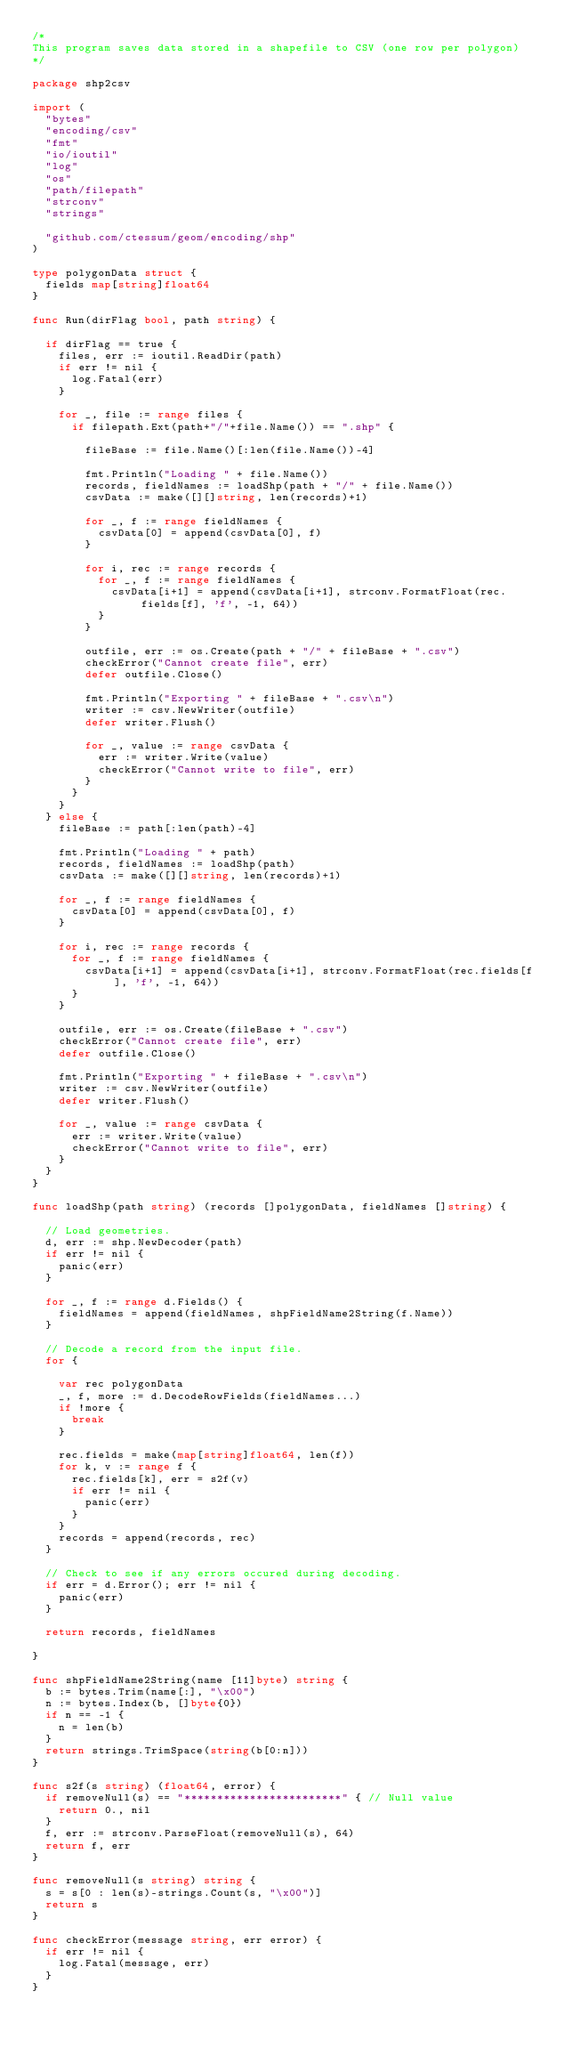<code> <loc_0><loc_0><loc_500><loc_500><_Go_>/*
This program saves data stored in a shapefile to CSV (one row per polygon)
*/

package shp2csv

import (
	"bytes"
	"encoding/csv"
	"fmt"
	"io/ioutil"
	"log"
	"os"
	"path/filepath"
	"strconv"
	"strings"

	"github.com/ctessum/geom/encoding/shp"
)

type polygonData struct {
	fields map[string]float64
}

func Run(dirFlag bool, path string) {

	if dirFlag == true {
		files, err := ioutil.ReadDir(path)
		if err != nil {
			log.Fatal(err)
		}

		for _, file := range files {
			if filepath.Ext(path+"/"+file.Name()) == ".shp" {

				fileBase := file.Name()[:len(file.Name())-4]

				fmt.Println("Loading " + file.Name())
				records, fieldNames := loadShp(path + "/" + file.Name())
				csvData := make([][]string, len(records)+1)

				for _, f := range fieldNames {
					csvData[0] = append(csvData[0], f)
				}

				for i, rec := range records {
					for _, f := range fieldNames {
						csvData[i+1] = append(csvData[i+1], strconv.FormatFloat(rec.fields[f], 'f', -1, 64))
					}
				}

				outfile, err := os.Create(path + "/" + fileBase + ".csv")
				checkError("Cannot create file", err)
				defer outfile.Close()

				fmt.Println("Exporting " + fileBase + ".csv\n")
				writer := csv.NewWriter(outfile)
				defer writer.Flush()

				for _, value := range csvData {
					err := writer.Write(value)
					checkError("Cannot write to file", err)
				}
			}
		}
	} else {
		fileBase := path[:len(path)-4]

		fmt.Println("Loading " + path)
		records, fieldNames := loadShp(path)
		csvData := make([][]string, len(records)+1)

		for _, f := range fieldNames {
			csvData[0] = append(csvData[0], f)
		}

		for i, rec := range records {
			for _, f := range fieldNames {
				csvData[i+1] = append(csvData[i+1], strconv.FormatFloat(rec.fields[f], 'f', -1, 64))
			}
		}

		outfile, err := os.Create(fileBase + ".csv")
		checkError("Cannot create file", err)
		defer outfile.Close()

		fmt.Println("Exporting " + fileBase + ".csv\n")
		writer := csv.NewWriter(outfile)
		defer writer.Flush()

		for _, value := range csvData {
			err := writer.Write(value)
			checkError("Cannot write to file", err)
		}
	}
}

func loadShp(path string) (records []polygonData, fieldNames []string) {

	// Load geometries.
	d, err := shp.NewDecoder(path)
	if err != nil {
		panic(err)
	}

	for _, f := range d.Fields() {
		fieldNames = append(fieldNames, shpFieldName2String(f.Name))
	}

	// Decode a record from the input file.
	for {

		var rec polygonData
		_, f, more := d.DecodeRowFields(fieldNames...)
		if !more {
			break
		}

		rec.fields = make(map[string]float64, len(f))
		for k, v := range f {
			rec.fields[k], err = s2f(v)
			if err != nil {
				panic(err)
			}
		}
		records = append(records, rec)
	}

	// Check to see if any errors occured during decoding.
	if err = d.Error(); err != nil {
		panic(err)
	}

	return records, fieldNames

}

func shpFieldName2String(name [11]byte) string {
	b := bytes.Trim(name[:], "\x00")
	n := bytes.Index(b, []byte{0})
	if n == -1 {
		n = len(b)
	}
	return strings.TrimSpace(string(b[0:n]))
}

func s2f(s string) (float64, error) {
	if removeNull(s) == "************************" { // Null value
		return 0., nil
	}
	f, err := strconv.ParseFloat(removeNull(s), 64)
	return f, err
}

func removeNull(s string) string {
	s = s[0 : len(s)-strings.Count(s, "\x00")]
	return s
}

func checkError(message string, err error) {
	if err != nil {
		log.Fatal(message, err)
	}
}
</code> 